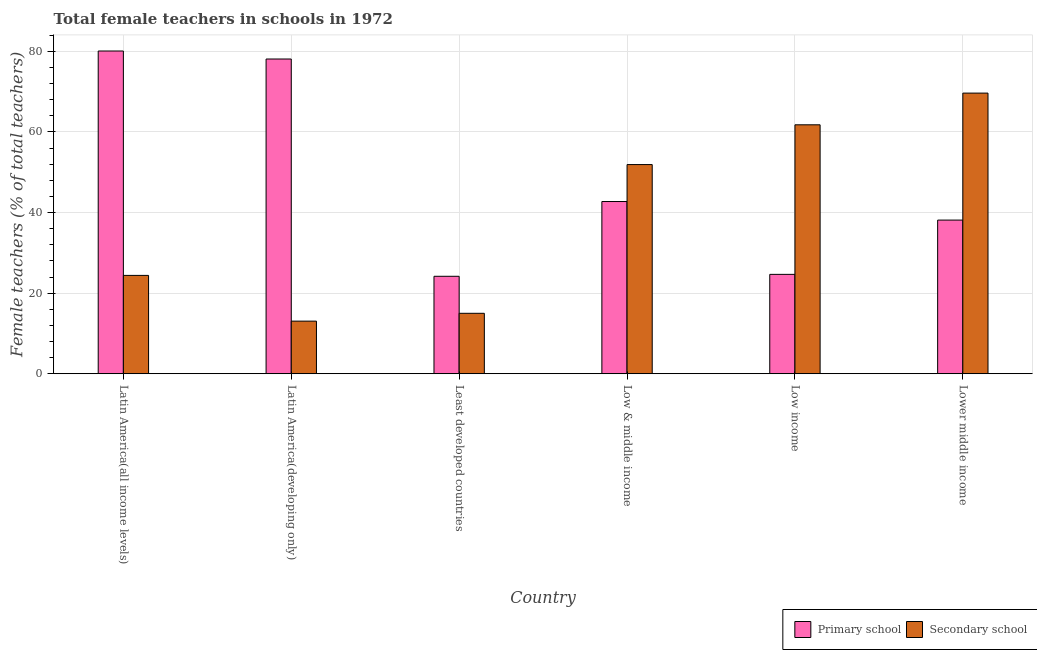Are the number of bars per tick equal to the number of legend labels?
Your answer should be compact. Yes. Are the number of bars on each tick of the X-axis equal?
Your answer should be very brief. Yes. What is the label of the 6th group of bars from the left?
Offer a terse response. Lower middle income. What is the percentage of female teachers in primary schools in Low & middle income?
Your answer should be very brief. 42.74. Across all countries, what is the maximum percentage of female teachers in secondary schools?
Offer a terse response. 69.65. Across all countries, what is the minimum percentage of female teachers in primary schools?
Provide a succinct answer. 24.18. In which country was the percentage of female teachers in primary schools maximum?
Keep it short and to the point. Latin America(all income levels). In which country was the percentage of female teachers in secondary schools minimum?
Your response must be concise. Latin America(developing only). What is the total percentage of female teachers in primary schools in the graph?
Provide a short and direct response. 287.94. What is the difference between the percentage of female teachers in primary schools in Low & middle income and that in Lower middle income?
Provide a succinct answer. 4.61. What is the difference between the percentage of female teachers in secondary schools in Lower middle income and the percentage of female teachers in primary schools in Least developed countries?
Make the answer very short. 45.47. What is the average percentage of female teachers in primary schools per country?
Your answer should be very brief. 47.99. What is the difference between the percentage of female teachers in primary schools and percentage of female teachers in secondary schools in Latin America(all income levels)?
Ensure brevity in your answer.  55.69. In how many countries, is the percentage of female teachers in secondary schools greater than 64 %?
Offer a very short reply. 1. What is the ratio of the percentage of female teachers in secondary schools in Least developed countries to that in Low & middle income?
Make the answer very short. 0.29. Is the difference between the percentage of female teachers in primary schools in Latin America(developing only) and Least developed countries greater than the difference between the percentage of female teachers in secondary schools in Latin America(developing only) and Least developed countries?
Ensure brevity in your answer.  Yes. What is the difference between the highest and the second highest percentage of female teachers in secondary schools?
Make the answer very short. 7.87. What is the difference between the highest and the lowest percentage of female teachers in secondary schools?
Your answer should be very brief. 56.6. Is the sum of the percentage of female teachers in secondary schools in Latin America(all income levels) and Latin America(developing only) greater than the maximum percentage of female teachers in primary schools across all countries?
Offer a very short reply. No. What does the 1st bar from the left in Low income represents?
Offer a very short reply. Primary school. What does the 2nd bar from the right in Least developed countries represents?
Give a very brief answer. Primary school. Are all the bars in the graph horizontal?
Make the answer very short. No. How many countries are there in the graph?
Give a very brief answer. 6. What is the difference between two consecutive major ticks on the Y-axis?
Provide a succinct answer. 20. Does the graph contain any zero values?
Keep it short and to the point. No. Does the graph contain grids?
Give a very brief answer. Yes. How are the legend labels stacked?
Your response must be concise. Horizontal. What is the title of the graph?
Your answer should be compact. Total female teachers in schools in 1972. Does "From production" appear as one of the legend labels in the graph?
Ensure brevity in your answer.  No. What is the label or title of the Y-axis?
Your answer should be very brief. Female teachers (% of total teachers). What is the Female teachers (% of total teachers) in Primary school in Latin America(all income levels)?
Offer a terse response. 80.1. What is the Female teachers (% of total teachers) in Secondary school in Latin America(all income levels)?
Your answer should be compact. 24.41. What is the Female teachers (% of total teachers) in Primary school in Latin America(developing only)?
Your response must be concise. 78.12. What is the Female teachers (% of total teachers) of Secondary school in Latin America(developing only)?
Provide a succinct answer. 13.06. What is the Female teachers (% of total teachers) in Primary school in Least developed countries?
Offer a very short reply. 24.18. What is the Female teachers (% of total teachers) in Primary school in Low & middle income?
Keep it short and to the point. 42.74. What is the Female teachers (% of total teachers) in Secondary school in Low & middle income?
Your response must be concise. 51.91. What is the Female teachers (% of total teachers) in Primary school in Low income?
Your response must be concise. 24.66. What is the Female teachers (% of total teachers) of Secondary school in Low income?
Provide a succinct answer. 61.78. What is the Female teachers (% of total teachers) in Primary school in Lower middle income?
Provide a succinct answer. 38.13. What is the Female teachers (% of total teachers) in Secondary school in Lower middle income?
Offer a very short reply. 69.65. Across all countries, what is the maximum Female teachers (% of total teachers) of Primary school?
Provide a succinct answer. 80.1. Across all countries, what is the maximum Female teachers (% of total teachers) in Secondary school?
Keep it short and to the point. 69.65. Across all countries, what is the minimum Female teachers (% of total teachers) of Primary school?
Offer a very short reply. 24.18. Across all countries, what is the minimum Female teachers (% of total teachers) in Secondary school?
Your answer should be compact. 13.06. What is the total Female teachers (% of total teachers) in Primary school in the graph?
Ensure brevity in your answer.  287.94. What is the total Female teachers (% of total teachers) in Secondary school in the graph?
Provide a short and direct response. 235.82. What is the difference between the Female teachers (% of total teachers) in Primary school in Latin America(all income levels) and that in Latin America(developing only)?
Provide a succinct answer. 1.98. What is the difference between the Female teachers (% of total teachers) of Secondary school in Latin America(all income levels) and that in Latin America(developing only)?
Your answer should be very brief. 11.35. What is the difference between the Female teachers (% of total teachers) of Primary school in Latin America(all income levels) and that in Least developed countries?
Offer a very short reply. 55.91. What is the difference between the Female teachers (% of total teachers) in Secondary school in Latin America(all income levels) and that in Least developed countries?
Keep it short and to the point. 9.41. What is the difference between the Female teachers (% of total teachers) of Primary school in Latin America(all income levels) and that in Low & middle income?
Make the answer very short. 37.36. What is the difference between the Female teachers (% of total teachers) of Secondary school in Latin America(all income levels) and that in Low & middle income?
Offer a very short reply. -27.51. What is the difference between the Female teachers (% of total teachers) of Primary school in Latin America(all income levels) and that in Low income?
Make the answer very short. 55.44. What is the difference between the Female teachers (% of total teachers) in Secondary school in Latin America(all income levels) and that in Low income?
Your answer should be very brief. -37.38. What is the difference between the Female teachers (% of total teachers) of Primary school in Latin America(all income levels) and that in Lower middle income?
Offer a very short reply. 41.97. What is the difference between the Female teachers (% of total teachers) in Secondary school in Latin America(all income levels) and that in Lower middle income?
Make the answer very short. -45.25. What is the difference between the Female teachers (% of total teachers) of Primary school in Latin America(developing only) and that in Least developed countries?
Your answer should be compact. 53.93. What is the difference between the Female teachers (% of total teachers) in Secondary school in Latin America(developing only) and that in Least developed countries?
Your response must be concise. -1.94. What is the difference between the Female teachers (% of total teachers) of Primary school in Latin America(developing only) and that in Low & middle income?
Provide a succinct answer. 35.37. What is the difference between the Female teachers (% of total teachers) of Secondary school in Latin America(developing only) and that in Low & middle income?
Provide a succinct answer. -38.86. What is the difference between the Female teachers (% of total teachers) of Primary school in Latin America(developing only) and that in Low income?
Your answer should be very brief. 53.45. What is the difference between the Female teachers (% of total teachers) of Secondary school in Latin America(developing only) and that in Low income?
Offer a very short reply. -48.72. What is the difference between the Female teachers (% of total teachers) of Primary school in Latin America(developing only) and that in Lower middle income?
Give a very brief answer. 39.98. What is the difference between the Female teachers (% of total teachers) of Secondary school in Latin America(developing only) and that in Lower middle income?
Make the answer very short. -56.6. What is the difference between the Female teachers (% of total teachers) in Primary school in Least developed countries and that in Low & middle income?
Your answer should be compact. -18.56. What is the difference between the Female teachers (% of total teachers) of Secondary school in Least developed countries and that in Low & middle income?
Your answer should be compact. -36.91. What is the difference between the Female teachers (% of total teachers) of Primary school in Least developed countries and that in Low income?
Your answer should be compact. -0.48. What is the difference between the Female teachers (% of total teachers) in Secondary school in Least developed countries and that in Low income?
Offer a very short reply. -46.78. What is the difference between the Female teachers (% of total teachers) in Primary school in Least developed countries and that in Lower middle income?
Offer a very short reply. -13.95. What is the difference between the Female teachers (% of total teachers) in Secondary school in Least developed countries and that in Lower middle income?
Provide a short and direct response. -54.65. What is the difference between the Female teachers (% of total teachers) of Primary school in Low & middle income and that in Low income?
Make the answer very short. 18.08. What is the difference between the Female teachers (% of total teachers) in Secondary school in Low & middle income and that in Low income?
Keep it short and to the point. -9.87. What is the difference between the Female teachers (% of total teachers) in Primary school in Low & middle income and that in Lower middle income?
Ensure brevity in your answer.  4.61. What is the difference between the Female teachers (% of total teachers) of Secondary school in Low & middle income and that in Lower middle income?
Provide a succinct answer. -17.74. What is the difference between the Female teachers (% of total teachers) in Primary school in Low income and that in Lower middle income?
Provide a succinct answer. -13.47. What is the difference between the Female teachers (% of total teachers) of Secondary school in Low income and that in Lower middle income?
Provide a succinct answer. -7.87. What is the difference between the Female teachers (% of total teachers) of Primary school in Latin America(all income levels) and the Female teachers (% of total teachers) of Secondary school in Latin America(developing only)?
Provide a succinct answer. 67.04. What is the difference between the Female teachers (% of total teachers) in Primary school in Latin America(all income levels) and the Female teachers (% of total teachers) in Secondary school in Least developed countries?
Offer a very short reply. 65.1. What is the difference between the Female teachers (% of total teachers) of Primary school in Latin America(all income levels) and the Female teachers (% of total teachers) of Secondary school in Low & middle income?
Your answer should be very brief. 28.18. What is the difference between the Female teachers (% of total teachers) in Primary school in Latin America(all income levels) and the Female teachers (% of total teachers) in Secondary school in Low income?
Your response must be concise. 18.32. What is the difference between the Female teachers (% of total teachers) in Primary school in Latin America(all income levels) and the Female teachers (% of total teachers) in Secondary school in Lower middle income?
Keep it short and to the point. 10.45. What is the difference between the Female teachers (% of total teachers) of Primary school in Latin America(developing only) and the Female teachers (% of total teachers) of Secondary school in Least developed countries?
Keep it short and to the point. 63.12. What is the difference between the Female teachers (% of total teachers) of Primary school in Latin America(developing only) and the Female teachers (% of total teachers) of Secondary school in Low & middle income?
Your response must be concise. 26.2. What is the difference between the Female teachers (% of total teachers) in Primary school in Latin America(developing only) and the Female teachers (% of total teachers) in Secondary school in Low income?
Offer a very short reply. 16.33. What is the difference between the Female teachers (% of total teachers) of Primary school in Latin America(developing only) and the Female teachers (% of total teachers) of Secondary school in Lower middle income?
Your answer should be compact. 8.46. What is the difference between the Female teachers (% of total teachers) in Primary school in Least developed countries and the Female teachers (% of total teachers) in Secondary school in Low & middle income?
Make the answer very short. -27.73. What is the difference between the Female teachers (% of total teachers) of Primary school in Least developed countries and the Female teachers (% of total teachers) of Secondary school in Low income?
Offer a very short reply. -37.6. What is the difference between the Female teachers (% of total teachers) in Primary school in Least developed countries and the Female teachers (% of total teachers) in Secondary school in Lower middle income?
Offer a very short reply. -45.47. What is the difference between the Female teachers (% of total teachers) in Primary school in Low & middle income and the Female teachers (% of total teachers) in Secondary school in Low income?
Your response must be concise. -19.04. What is the difference between the Female teachers (% of total teachers) in Primary school in Low & middle income and the Female teachers (% of total teachers) in Secondary school in Lower middle income?
Give a very brief answer. -26.91. What is the difference between the Female teachers (% of total teachers) in Primary school in Low income and the Female teachers (% of total teachers) in Secondary school in Lower middle income?
Ensure brevity in your answer.  -44.99. What is the average Female teachers (% of total teachers) of Primary school per country?
Provide a short and direct response. 47.99. What is the average Female teachers (% of total teachers) in Secondary school per country?
Give a very brief answer. 39.3. What is the difference between the Female teachers (% of total teachers) of Primary school and Female teachers (% of total teachers) of Secondary school in Latin America(all income levels)?
Provide a short and direct response. 55.69. What is the difference between the Female teachers (% of total teachers) in Primary school and Female teachers (% of total teachers) in Secondary school in Latin America(developing only)?
Your answer should be very brief. 65.06. What is the difference between the Female teachers (% of total teachers) in Primary school and Female teachers (% of total teachers) in Secondary school in Least developed countries?
Ensure brevity in your answer.  9.18. What is the difference between the Female teachers (% of total teachers) of Primary school and Female teachers (% of total teachers) of Secondary school in Low & middle income?
Offer a very short reply. -9.17. What is the difference between the Female teachers (% of total teachers) of Primary school and Female teachers (% of total teachers) of Secondary school in Low income?
Your answer should be compact. -37.12. What is the difference between the Female teachers (% of total teachers) in Primary school and Female teachers (% of total teachers) in Secondary school in Lower middle income?
Ensure brevity in your answer.  -31.52. What is the ratio of the Female teachers (% of total teachers) of Primary school in Latin America(all income levels) to that in Latin America(developing only)?
Your response must be concise. 1.03. What is the ratio of the Female teachers (% of total teachers) in Secondary school in Latin America(all income levels) to that in Latin America(developing only)?
Your answer should be very brief. 1.87. What is the ratio of the Female teachers (% of total teachers) in Primary school in Latin America(all income levels) to that in Least developed countries?
Provide a short and direct response. 3.31. What is the ratio of the Female teachers (% of total teachers) of Secondary school in Latin America(all income levels) to that in Least developed countries?
Make the answer very short. 1.63. What is the ratio of the Female teachers (% of total teachers) in Primary school in Latin America(all income levels) to that in Low & middle income?
Ensure brevity in your answer.  1.87. What is the ratio of the Female teachers (% of total teachers) of Secondary school in Latin America(all income levels) to that in Low & middle income?
Provide a succinct answer. 0.47. What is the ratio of the Female teachers (% of total teachers) of Primary school in Latin America(all income levels) to that in Low income?
Make the answer very short. 3.25. What is the ratio of the Female teachers (% of total teachers) of Secondary school in Latin America(all income levels) to that in Low income?
Keep it short and to the point. 0.4. What is the ratio of the Female teachers (% of total teachers) in Primary school in Latin America(all income levels) to that in Lower middle income?
Provide a succinct answer. 2.1. What is the ratio of the Female teachers (% of total teachers) of Secondary school in Latin America(all income levels) to that in Lower middle income?
Provide a succinct answer. 0.35. What is the ratio of the Female teachers (% of total teachers) of Primary school in Latin America(developing only) to that in Least developed countries?
Offer a terse response. 3.23. What is the ratio of the Female teachers (% of total teachers) of Secondary school in Latin America(developing only) to that in Least developed countries?
Offer a very short reply. 0.87. What is the ratio of the Female teachers (% of total teachers) of Primary school in Latin America(developing only) to that in Low & middle income?
Offer a terse response. 1.83. What is the ratio of the Female teachers (% of total teachers) in Secondary school in Latin America(developing only) to that in Low & middle income?
Your response must be concise. 0.25. What is the ratio of the Female teachers (% of total teachers) of Primary school in Latin America(developing only) to that in Low income?
Your response must be concise. 3.17. What is the ratio of the Female teachers (% of total teachers) of Secondary school in Latin America(developing only) to that in Low income?
Your response must be concise. 0.21. What is the ratio of the Female teachers (% of total teachers) of Primary school in Latin America(developing only) to that in Lower middle income?
Offer a terse response. 2.05. What is the ratio of the Female teachers (% of total teachers) in Secondary school in Latin America(developing only) to that in Lower middle income?
Your response must be concise. 0.19. What is the ratio of the Female teachers (% of total teachers) of Primary school in Least developed countries to that in Low & middle income?
Offer a terse response. 0.57. What is the ratio of the Female teachers (% of total teachers) in Secondary school in Least developed countries to that in Low & middle income?
Your answer should be compact. 0.29. What is the ratio of the Female teachers (% of total teachers) of Primary school in Least developed countries to that in Low income?
Ensure brevity in your answer.  0.98. What is the ratio of the Female teachers (% of total teachers) of Secondary school in Least developed countries to that in Low income?
Offer a very short reply. 0.24. What is the ratio of the Female teachers (% of total teachers) of Primary school in Least developed countries to that in Lower middle income?
Give a very brief answer. 0.63. What is the ratio of the Female teachers (% of total teachers) in Secondary school in Least developed countries to that in Lower middle income?
Offer a very short reply. 0.22. What is the ratio of the Female teachers (% of total teachers) of Primary school in Low & middle income to that in Low income?
Provide a succinct answer. 1.73. What is the ratio of the Female teachers (% of total teachers) in Secondary school in Low & middle income to that in Low income?
Your response must be concise. 0.84. What is the ratio of the Female teachers (% of total teachers) of Primary school in Low & middle income to that in Lower middle income?
Offer a very short reply. 1.12. What is the ratio of the Female teachers (% of total teachers) of Secondary school in Low & middle income to that in Lower middle income?
Provide a succinct answer. 0.75. What is the ratio of the Female teachers (% of total teachers) of Primary school in Low income to that in Lower middle income?
Offer a terse response. 0.65. What is the ratio of the Female teachers (% of total teachers) in Secondary school in Low income to that in Lower middle income?
Offer a terse response. 0.89. What is the difference between the highest and the second highest Female teachers (% of total teachers) of Primary school?
Provide a succinct answer. 1.98. What is the difference between the highest and the second highest Female teachers (% of total teachers) of Secondary school?
Offer a very short reply. 7.87. What is the difference between the highest and the lowest Female teachers (% of total teachers) of Primary school?
Make the answer very short. 55.91. What is the difference between the highest and the lowest Female teachers (% of total teachers) in Secondary school?
Offer a terse response. 56.6. 